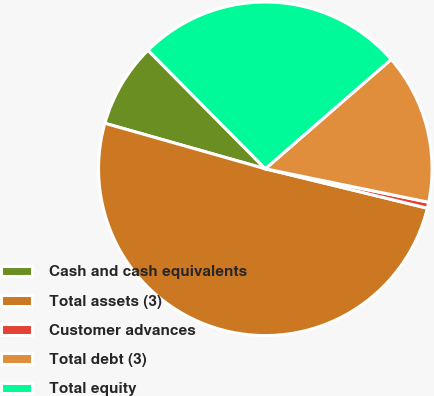<chart> <loc_0><loc_0><loc_500><loc_500><pie_chart><fcel>Cash and cash equivalents<fcel>Total assets (3)<fcel>Customer advances<fcel>Total debt (3)<fcel>Total equity<nl><fcel>8.19%<fcel>50.6%<fcel>0.58%<fcel>14.61%<fcel>26.02%<nl></chart> 